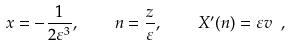Convert formula to latex. <formula><loc_0><loc_0><loc_500><loc_500>x = - \frac { 1 } { 2 \varepsilon ^ { 3 } } , \quad n = \frac { z } { \varepsilon } , \quad X ^ { \prime } ( n ) = \varepsilon v \ ,</formula> 